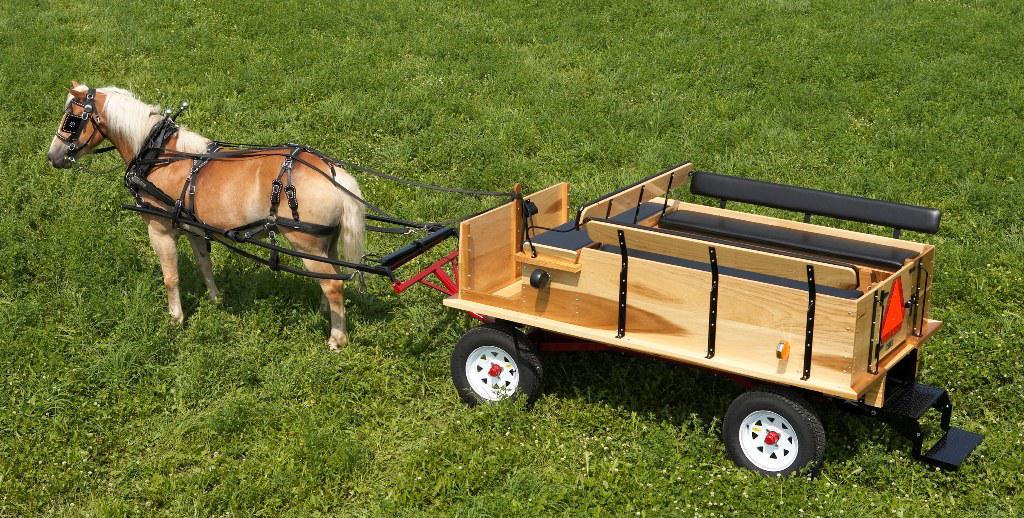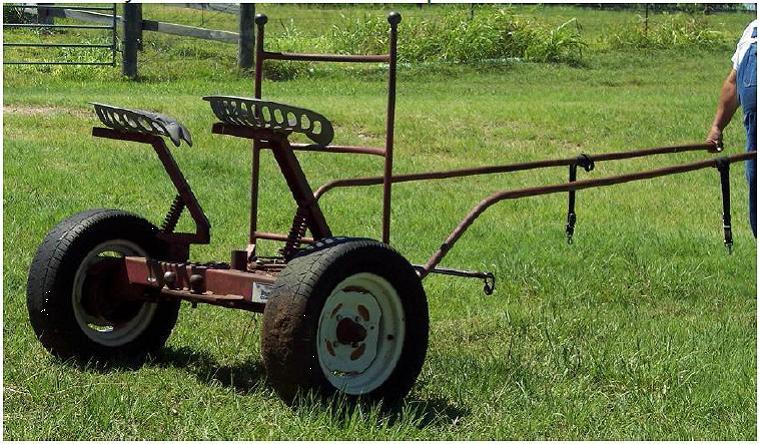The first image is the image on the left, the second image is the image on the right. For the images shown, is this caption "An image shows a brown horse harnessed to pull some type of wheeled thing." true? Answer yes or no. Yes. The first image is the image on the left, the second image is the image on the right. Considering the images on both sides, is "There is a picture showing a horse hitched up to a piece of equipment." valid? Answer yes or no. Yes. 